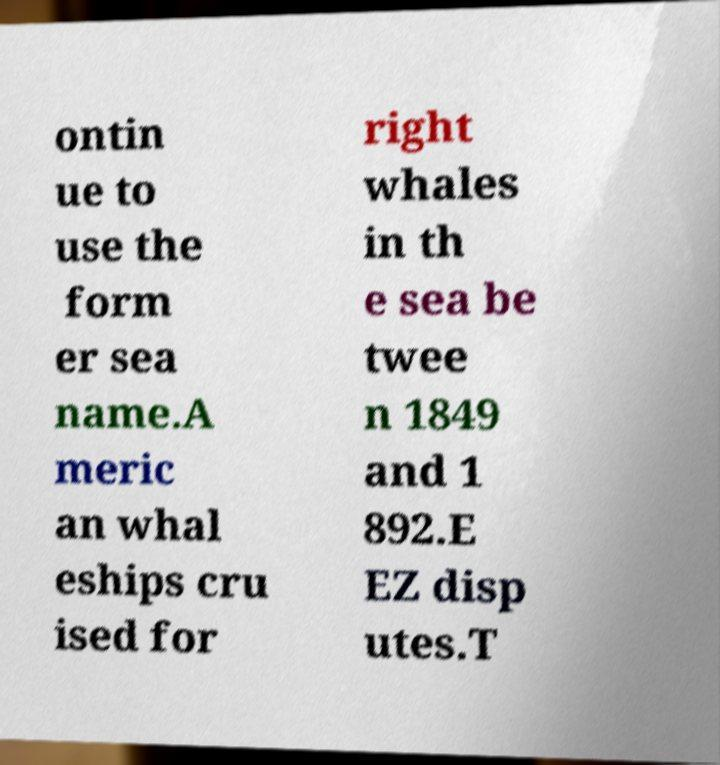For documentation purposes, I need the text within this image transcribed. Could you provide that? ontin ue to use the form er sea name.A meric an whal eships cru ised for right whales in th e sea be twee n 1849 and 1 892.E EZ disp utes.T 